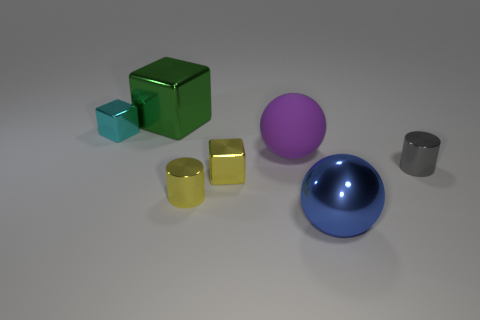Add 2 big purple balls. How many objects exist? 9 Subtract all cubes. How many objects are left? 4 Subtract all large brown matte balls. Subtract all large blue objects. How many objects are left? 6 Add 4 large blue metal things. How many large blue metal things are left? 5 Add 1 tiny gray matte blocks. How many tiny gray matte blocks exist? 1 Subtract 1 purple balls. How many objects are left? 6 